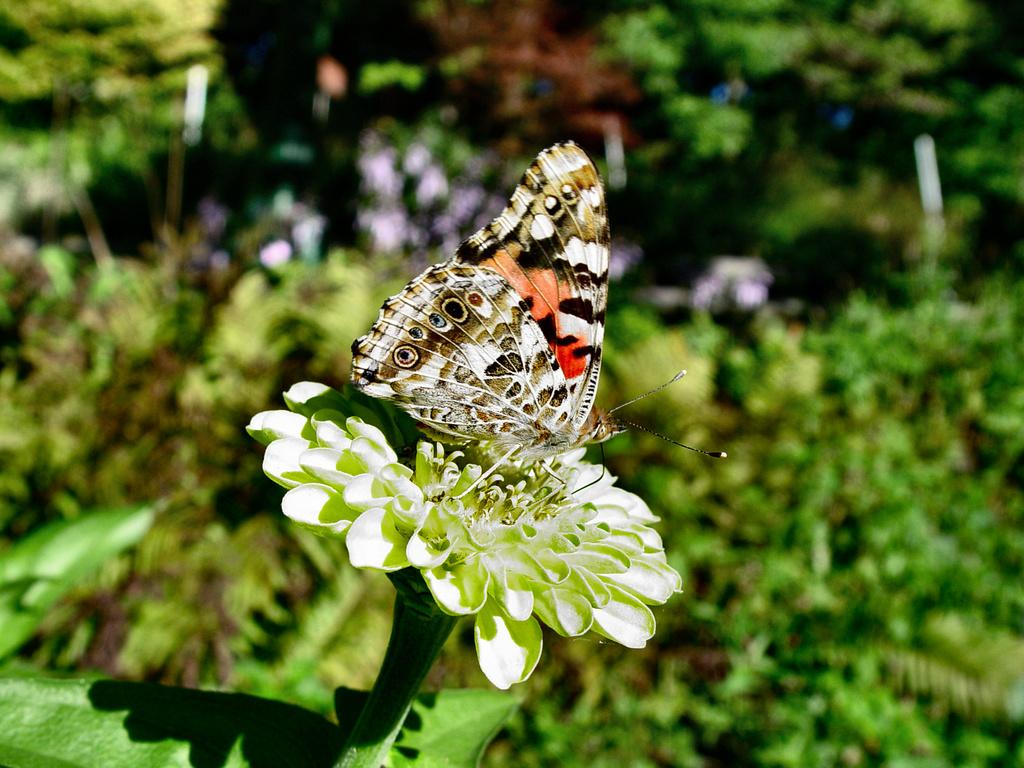What is on the flower in the image? There is a butterfly on a flower in the image. What type of vegetation can be seen in the image? Trees and plants are visible in the image. What type of tin can be seen in the image? There is no tin present in the image. How does the earthquake affect the butterfly in the image? There is no earthquake present in the image, so its effect on the butterfly cannot be determined. 